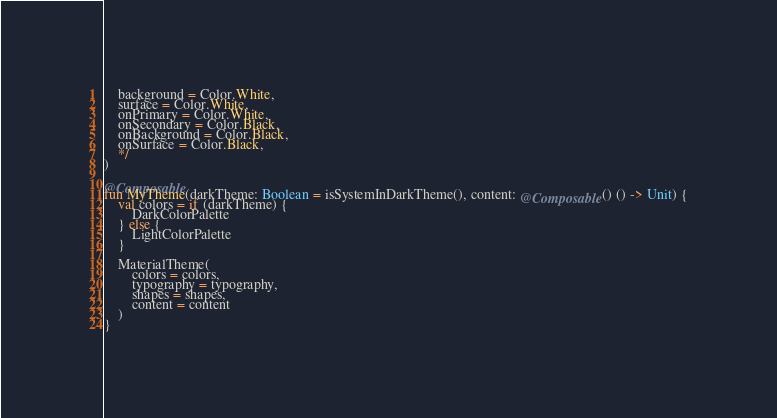<code> <loc_0><loc_0><loc_500><loc_500><_Kotlin_>    background = Color.White,
    surface = Color.White,
    onPrimary = Color.White,
    onSecondary = Color.Black,
    onBackground = Color.Black,
    onSurface = Color.Black,
    */
)

@Composable
fun MyTheme(darkTheme: Boolean = isSystemInDarkTheme(), content: @Composable() () -> Unit) {
    val colors = if (darkTheme) {
        DarkColorPalette
    } else {
        LightColorPalette
    }

    MaterialTheme(
        colors = colors,
        typography = typography,
        shapes = shapes,
        content = content
    )
}
</code> 